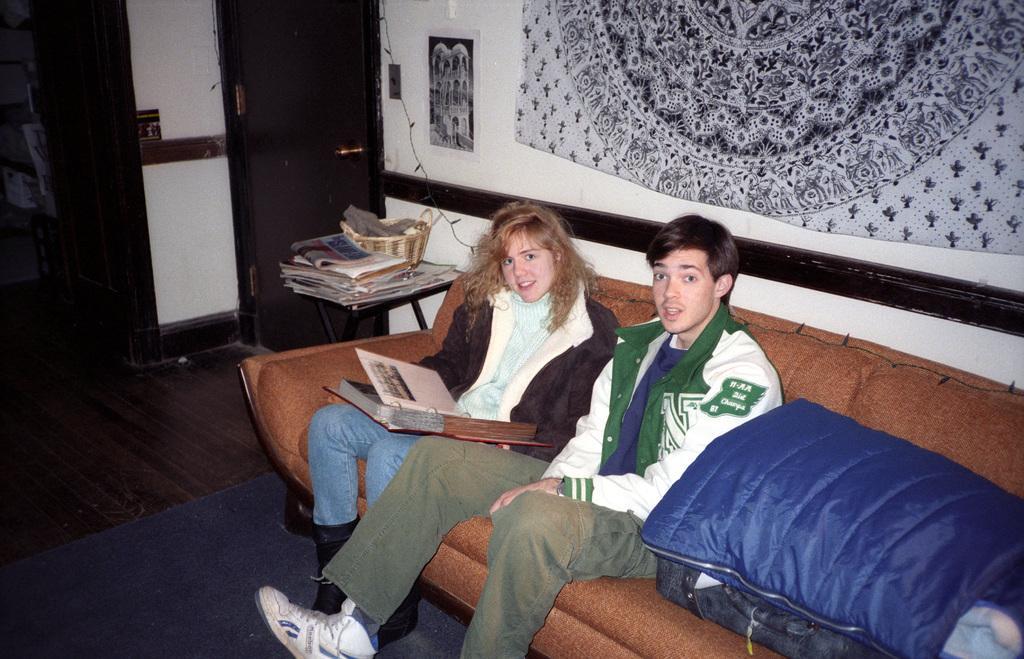Could you give a brief overview of what you see in this image? On the background we can see a door and a decorative wall. Here we can see two persons sitting on the sofa, she is holding an album in her hands. Near to them we can see a tabela nd on the table we can see basket and newspapers. This is a floor and a carpet. 